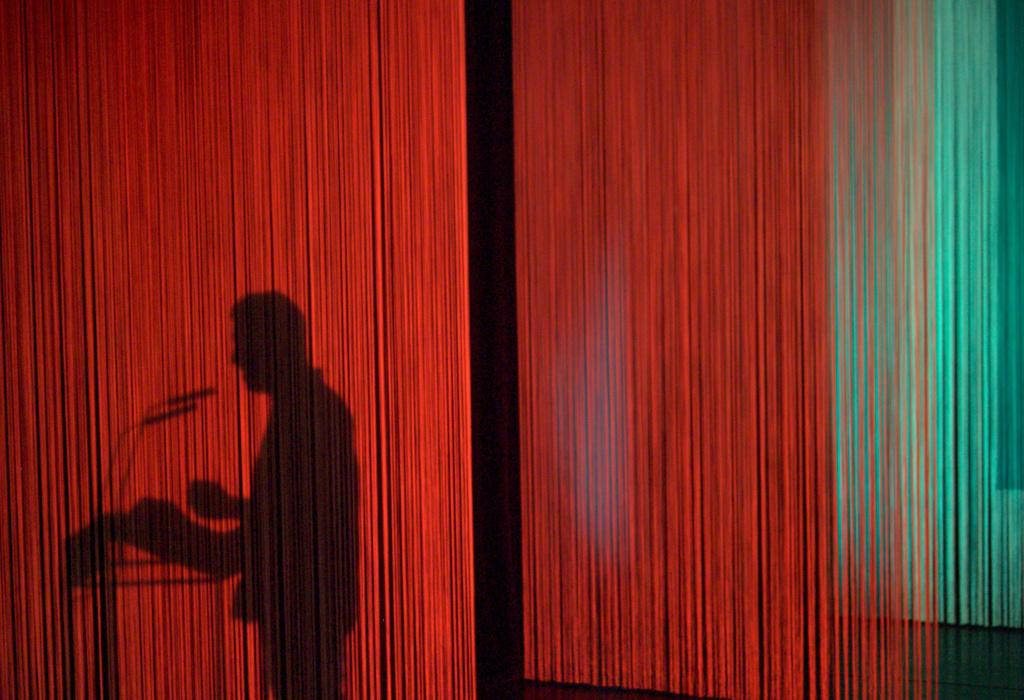What can be seen in the image through the shadows? There are shadows of a person and microphones in the image. What color is the red color object in the image? The red color object in the image is not described in detail, so we cannot determine its exact shade or hue. Can you describe the red color object in the image? The facts provided only mention that there is a red color object in the image, without specifying its shape or purpose. What type of rock is being used as a judge in the image? There is no rock or judge present in the image; it features shadows of a person and microphones, as well as a red color object. 